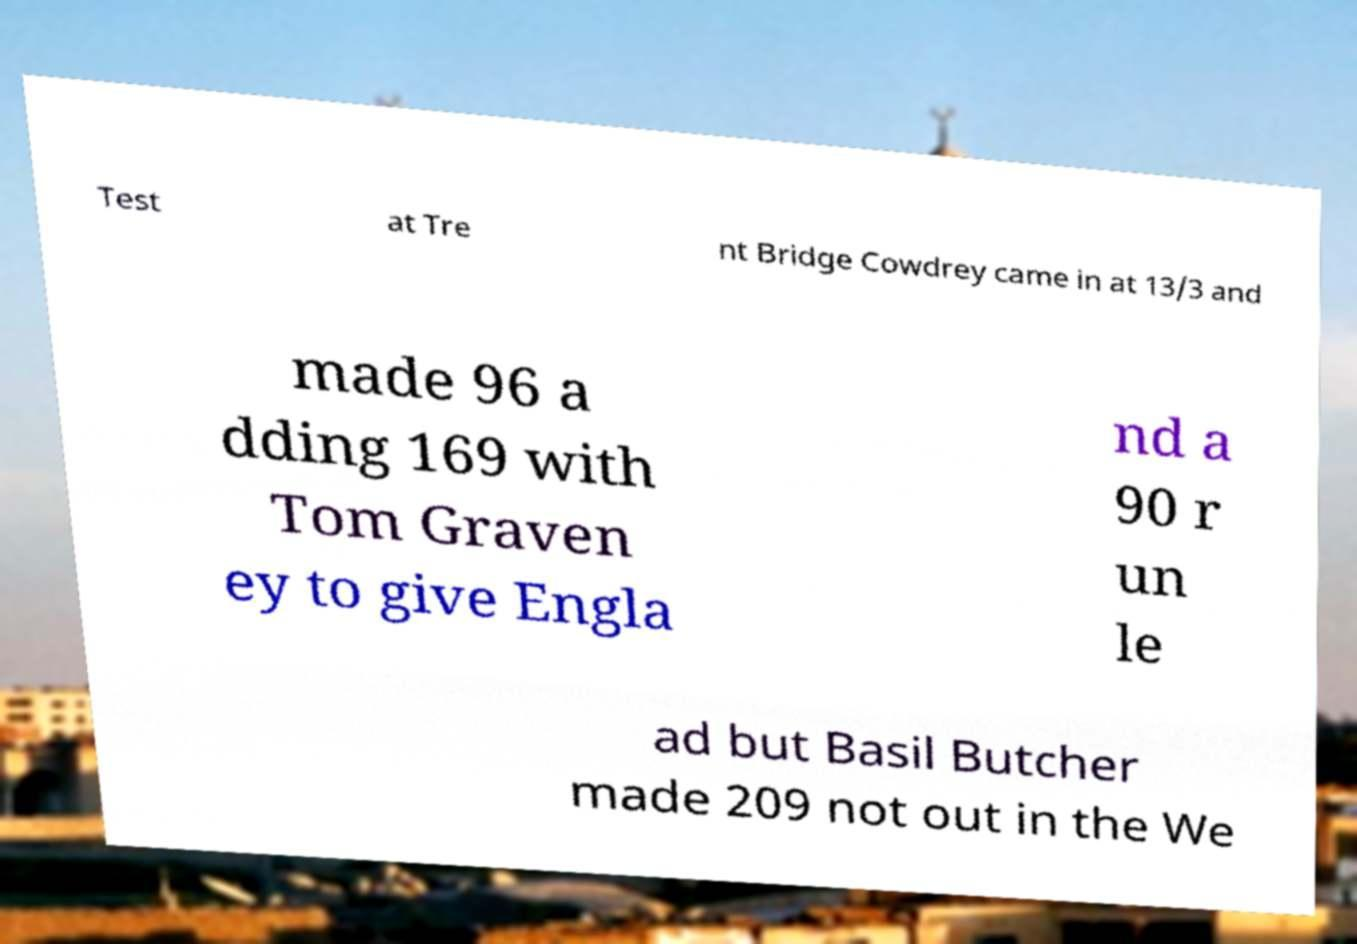Could you assist in decoding the text presented in this image and type it out clearly? Test at Tre nt Bridge Cowdrey came in at 13/3 and made 96 a dding 169 with Tom Graven ey to give Engla nd a 90 r un le ad but Basil Butcher made 209 not out in the We 